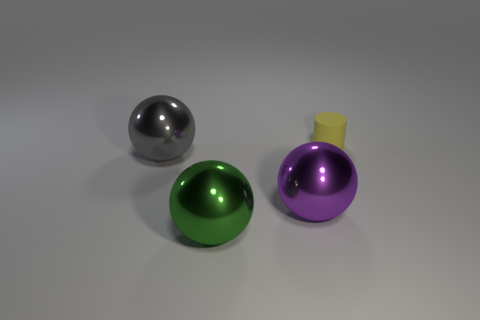What is the shape of the shiny thing that is to the left of the big shiny sphere that is in front of the large purple metallic object?
Keep it short and to the point. Sphere. There is a object that is behind the large metallic thing left of the green metal object; what size is it?
Your answer should be compact. Small. What is the shape of the gray object?
Ensure brevity in your answer.  Sphere. How many big things are green balls or gray balls?
Keep it short and to the point. 2. What size is the green metallic thing that is the same shape as the purple thing?
Keep it short and to the point. Large. How many things are behind the purple ball and on the left side of the small cylinder?
Ensure brevity in your answer.  1. There is a big green metallic thing; does it have the same shape as the shiny thing that is left of the big green sphere?
Offer a terse response. Yes. Is the number of spheres to the right of the green sphere greater than the number of large yellow metallic things?
Ensure brevity in your answer.  Yes. Is the number of yellow objects in front of the large gray shiny ball less than the number of large cyan metal blocks?
Provide a succinct answer. No. What number of rubber cylinders are the same color as the rubber object?
Your response must be concise. 0. 